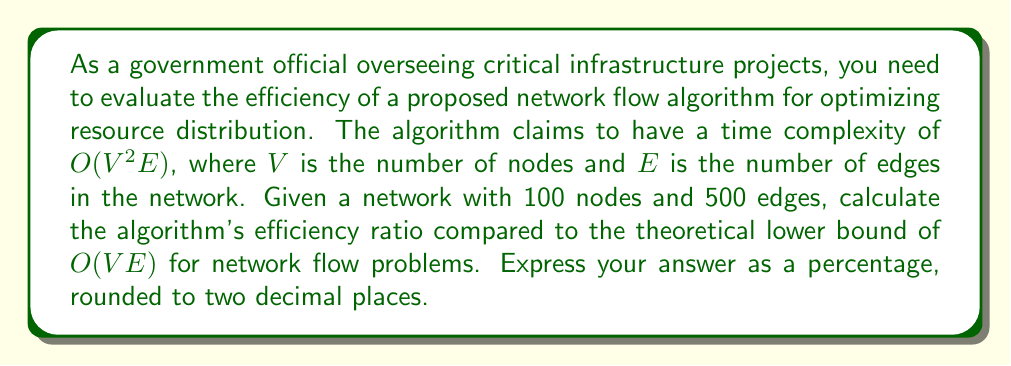Can you solve this math problem? To solve this problem, we need to follow these steps:

1) First, let's calculate the computational complexity for both the proposed algorithm and the theoretical lower bound:

   Proposed algorithm: $O(V^2E)$
   Theoretical lower bound: $O(VE)$

2) For the given network:
   $V = 100$ (nodes)
   $E = 500$ (edges)

3) Let's substitute these values:

   Proposed algorithm: $O((100)^2 * 500) = O(5,000,000)$
   Theoretical lower bound: $O(100 * 500) = O(50,000)$

4) The efficiency ratio can be calculated as:

   $$\text{Efficiency Ratio} = \frac{\text{Theoretical Lower Bound}}{\text{Proposed Algorithm}} * 100\%$$

5) Substituting the values:

   $$\text{Efficiency Ratio} = \frac{50,000}{5,000,000} * 100\% = 0.01 * 100\% = 1\%$$

6) Rounding to two decimal places, we get 1.00%

This means the proposed algorithm is operating at 1.00% efficiency compared to the theoretical lower bound, indicating significant room for improvement.
Answer: 1.00% 